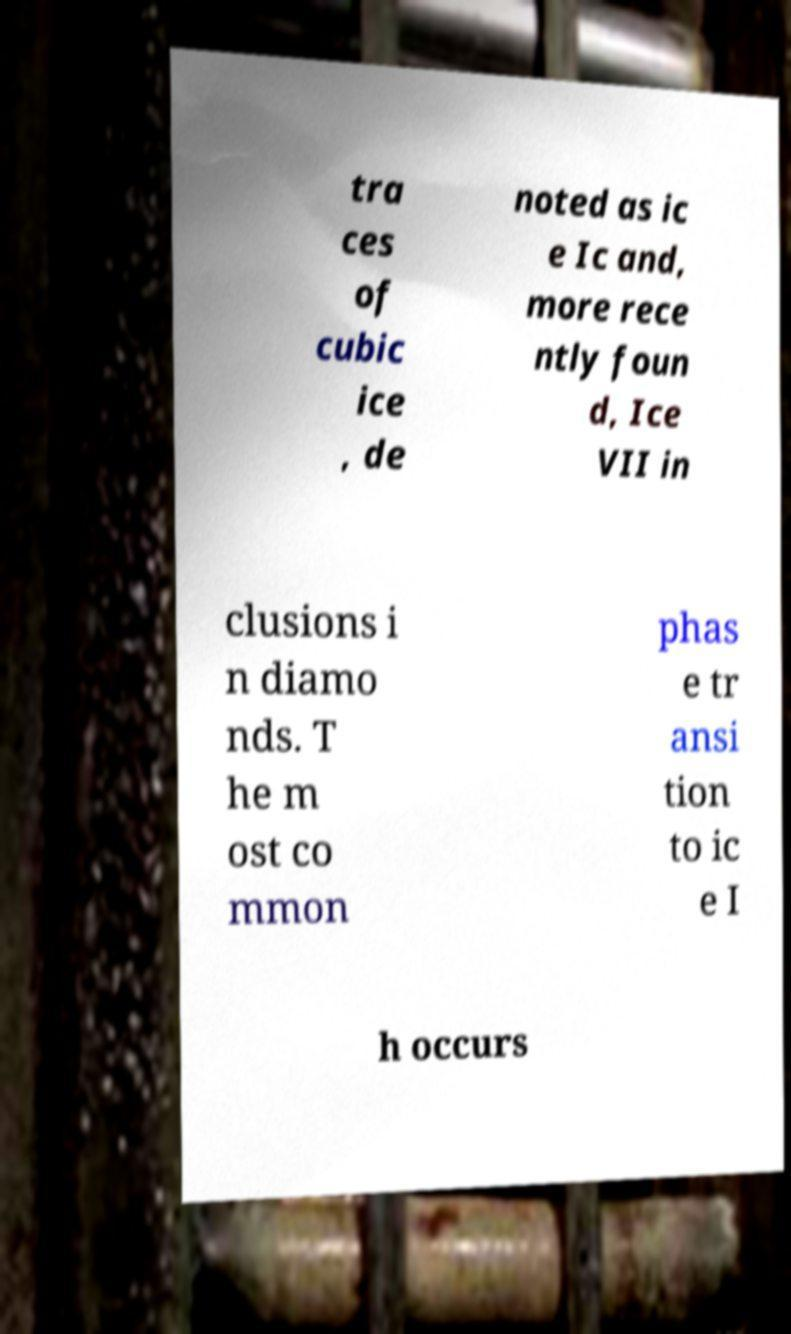Could you assist in decoding the text presented in this image and type it out clearly? tra ces of cubic ice , de noted as ic e Ic and, more rece ntly foun d, Ice VII in clusions i n diamo nds. T he m ost co mmon phas e tr ansi tion to ic e I h occurs 